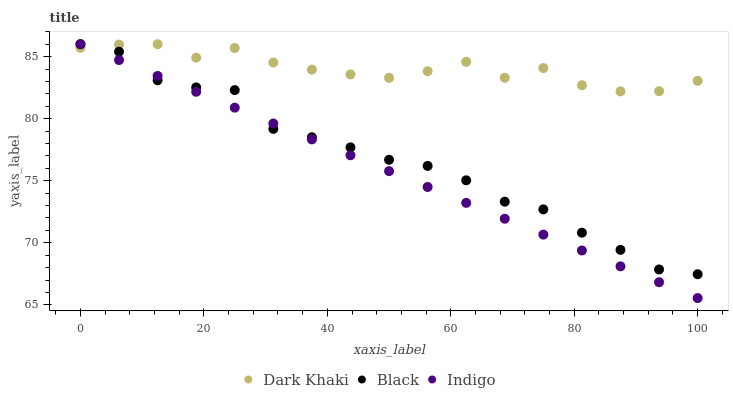Does Indigo have the minimum area under the curve?
Answer yes or no. Yes. Does Dark Khaki have the maximum area under the curve?
Answer yes or no. Yes. Does Black have the minimum area under the curve?
Answer yes or no. No. Does Black have the maximum area under the curve?
Answer yes or no. No. Is Indigo the smoothest?
Answer yes or no. Yes. Is Dark Khaki the roughest?
Answer yes or no. Yes. Is Black the smoothest?
Answer yes or no. No. Is Black the roughest?
Answer yes or no. No. Does Indigo have the lowest value?
Answer yes or no. Yes. Does Black have the lowest value?
Answer yes or no. No. Does Black have the highest value?
Answer yes or no. Yes. Does Indigo intersect Black?
Answer yes or no. Yes. Is Indigo less than Black?
Answer yes or no. No. Is Indigo greater than Black?
Answer yes or no. No. 